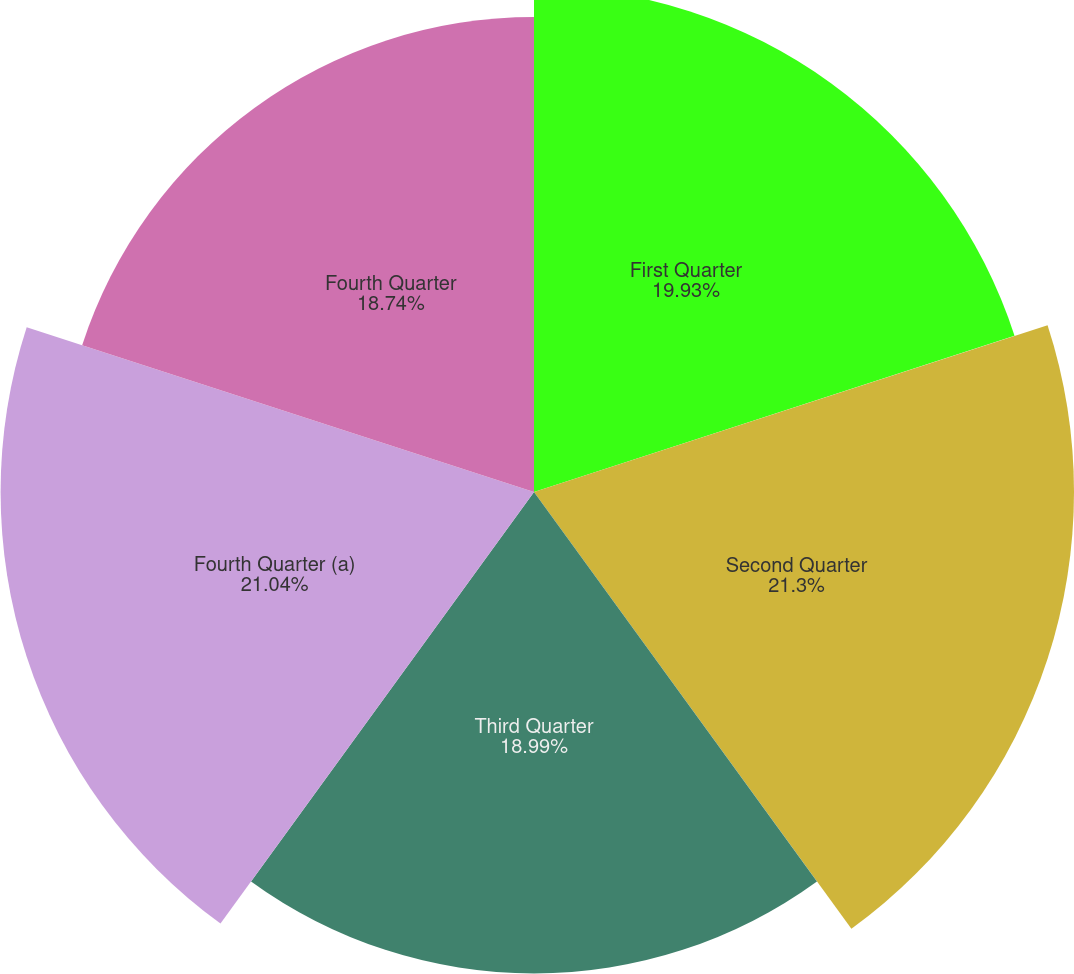Convert chart to OTSL. <chart><loc_0><loc_0><loc_500><loc_500><pie_chart><fcel>First Quarter<fcel>Second Quarter<fcel>Third Quarter<fcel>Fourth Quarter (a)<fcel>Fourth Quarter<nl><fcel>19.93%<fcel>21.3%<fcel>18.99%<fcel>21.04%<fcel>18.74%<nl></chart> 